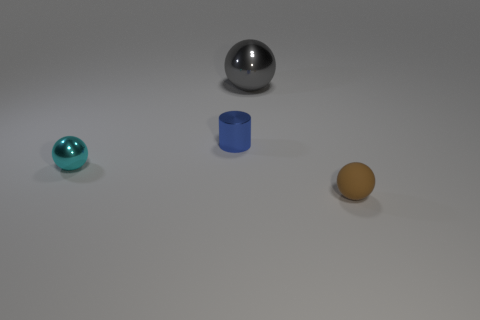Add 2 big red matte balls. How many objects exist? 6 Subtract all tiny balls. How many balls are left? 1 Subtract 2 spheres. How many spheres are left? 1 Subtract all spheres. How many objects are left? 1 Subtract all green cylinders. Subtract all green cubes. How many cylinders are left? 1 Subtract all matte things. Subtract all blue blocks. How many objects are left? 3 Add 4 blue metallic cylinders. How many blue metallic cylinders are left? 5 Add 4 small cyan metallic things. How many small cyan metallic things exist? 5 Subtract 0 blue spheres. How many objects are left? 4 